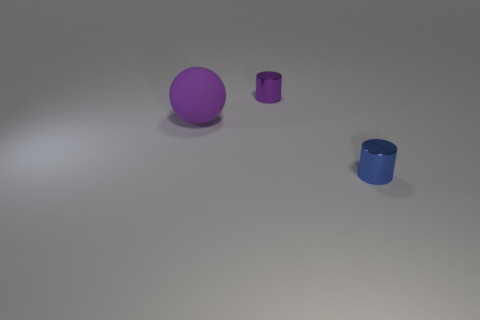How many tiny purple things have the same material as the tiny blue cylinder?
Your response must be concise. 1. There is a tiny cylinder that is behind the small blue metallic object; how many tiny purple cylinders are behind it?
Provide a succinct answer. 0. There is a object that is on the left side of the purple cylinder; is it the same color as the small thing that is behind the purple matte thing?
Make the answer very short. Yes. What shape is the object that is on the left side of the blue metallic cylinder and to the right of the big rubber thing?
Your response must be concise. Cylinder. Is there a purple metal object that has the same shape as the small blue metal thing?
Provide a succinct answer. Yes. What shape is the purple thing that is the same size as the blue shiny cylinder?
Your answer should be very brief. Cylinder. What is the blue thing made of?
Offer a very short reply. Metal. There is a thing that is left of the tiny object left of the small cylinder in front of the big rubber object; what is its size?
Provide a short and direct response. Large. How many metallic objects are either green blocks or spheres?
Ensure brevity in your answer.  0. The purple metal cylinder has what size?
Provide a succinct answer. Small. 